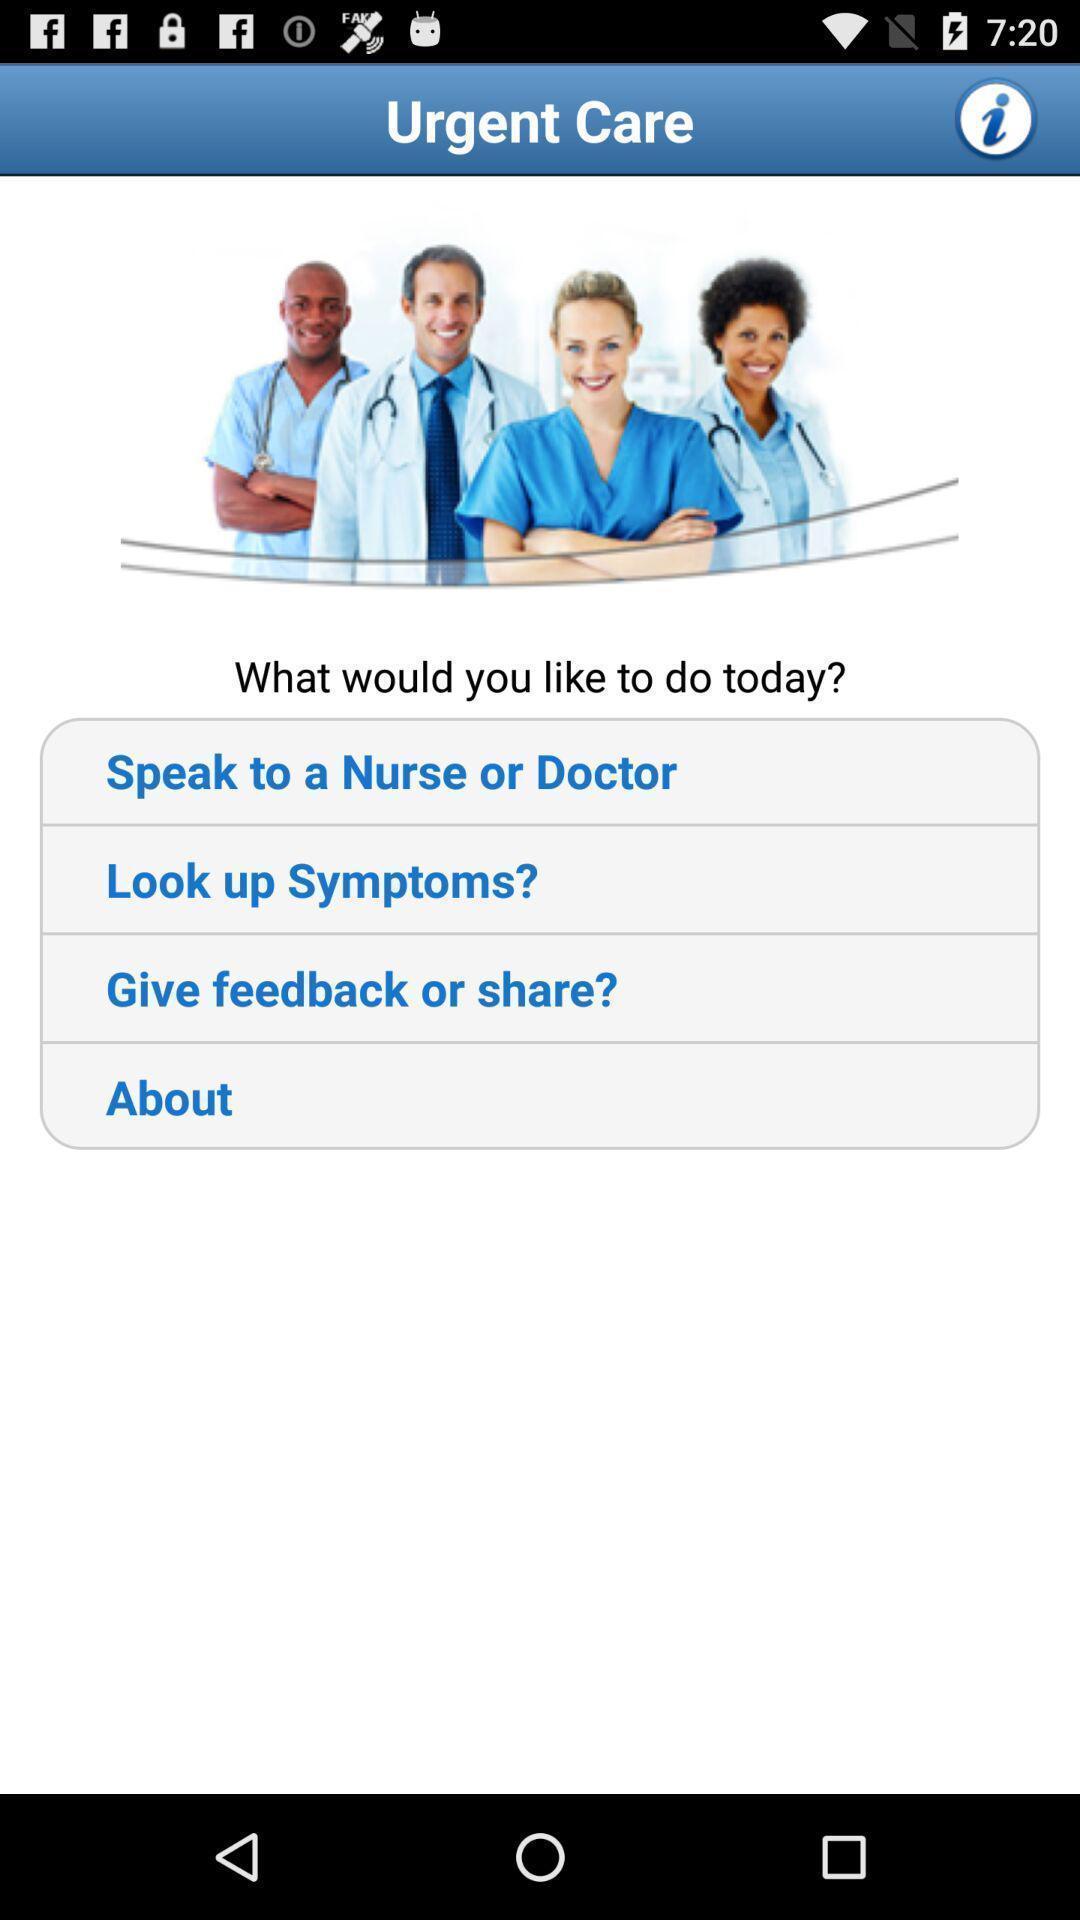What details can you identify in this image? Welcome page options for contact the health care. 